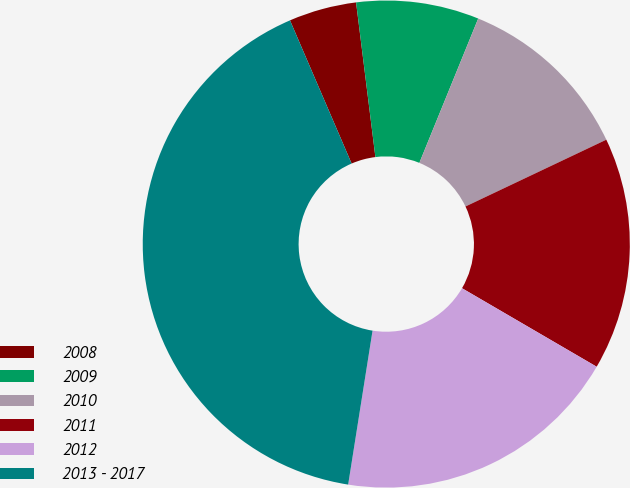<chart> <loc_0><loc_0><loc_500><loc_500><pie_chart><fcel>2008<fcel>2009<fcel>2010<fcel>2011<fcel>2012<fcel>2013 - 2017<nl><fcel>4.49%<fcel>8.14%<fcel>11.79%<fcel>15.45%<fcel>19.1%<fcel>41.03%<nl></chart> 